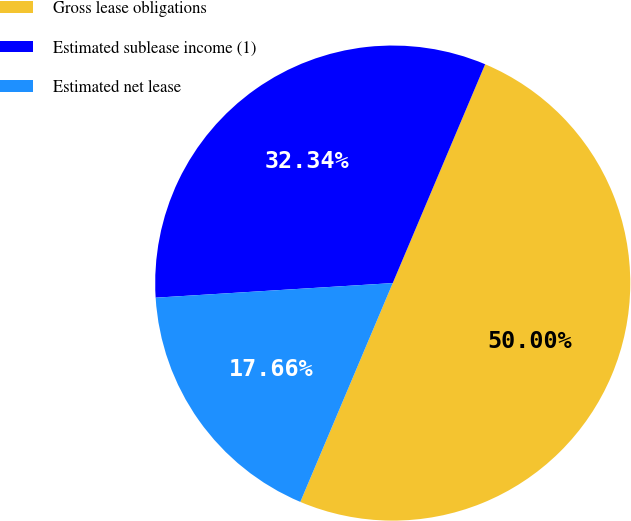<chart> <loc_0><loc_0><loc_500><loc_500><pie_chart><fcel>Gross lease obligations<fcel>Estimated sublease income (1)<fcel>Estimated net lease<nl><fcel>50.0%<fcel>32.34%<fcel>17.66%<nl></chart> 